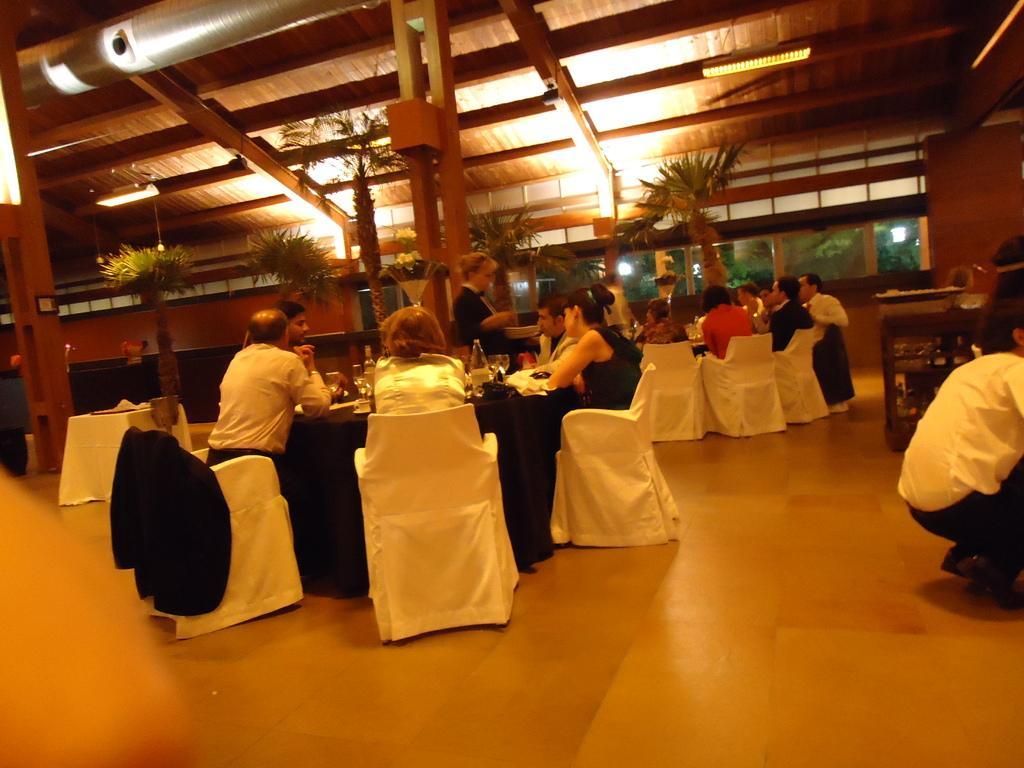Could you give a brief overview of what you see in this image? In this picture we can see a group of people sitting on chairs, tables with clothes and some objects on it, trees, wooden pillars and in the background we can see some objects, walls and windows. 